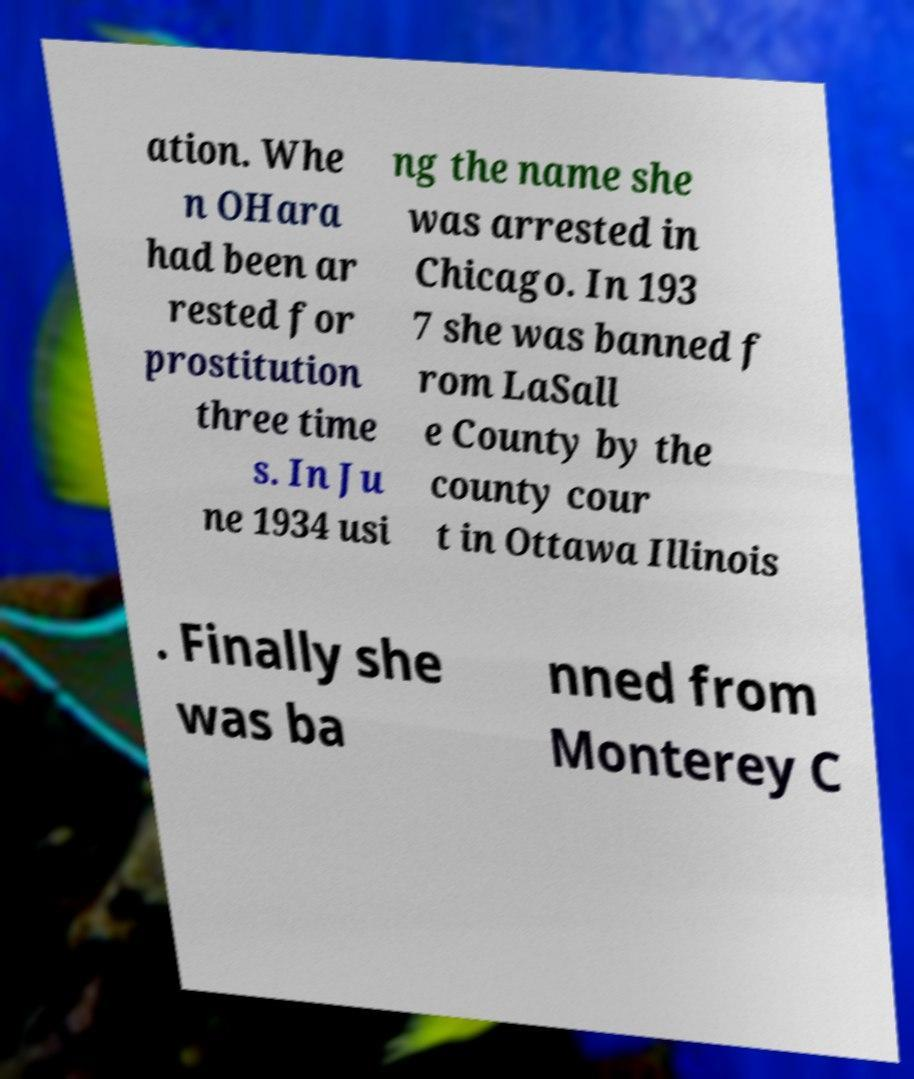Please identify and transcribe the text found in this image. ation. Whe n OHara had been ar rested for prostitution three time s. In Ju ne 1934 usi ng the name she was arrested in Chicago. In 193 7 she was banned f rom LaSall e County by the county cour t in Ottawa Illinois . Finally she was ba nned from Monterey C 